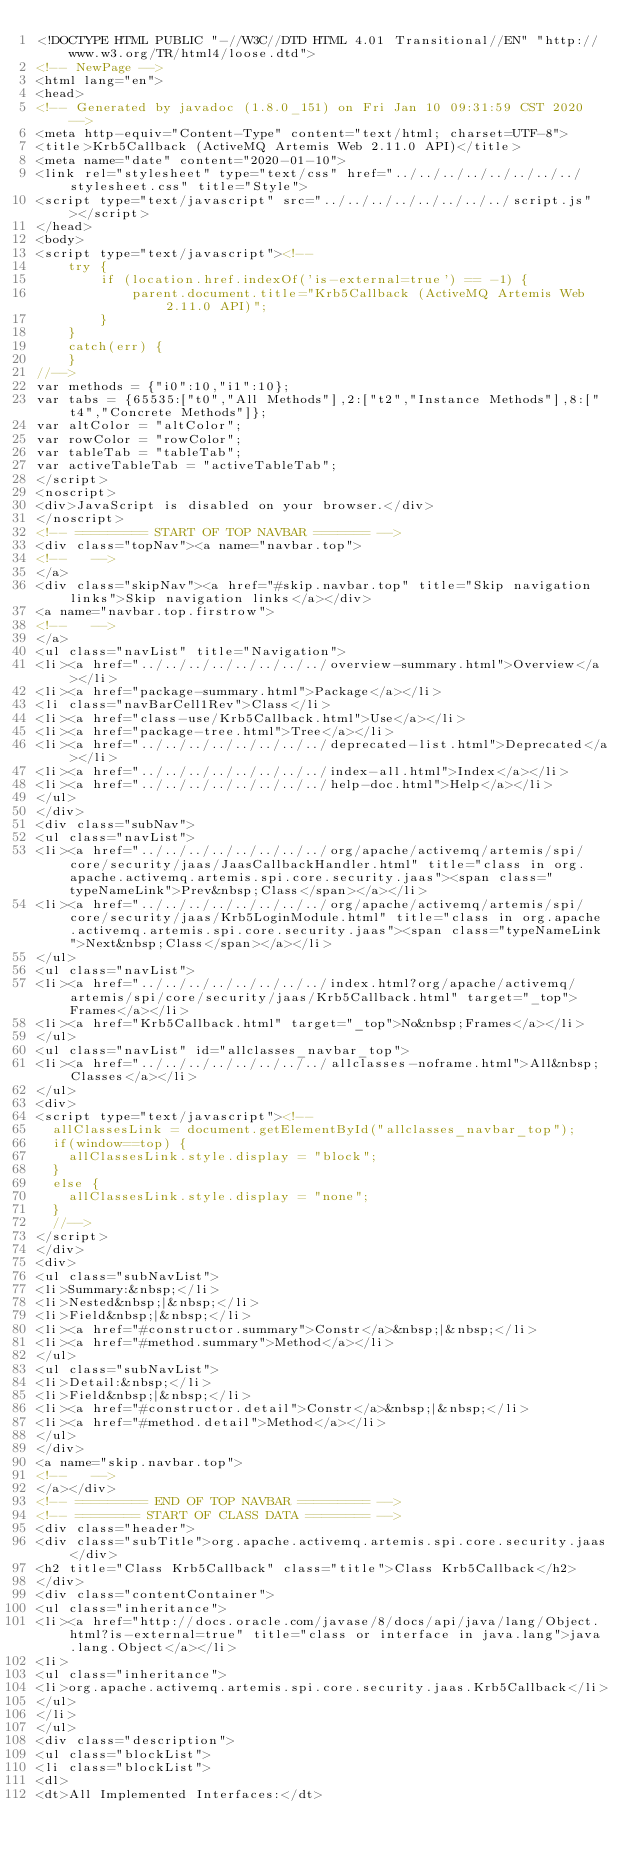Convert code to text. <code><loc_0><loc_0><loc_500><loc_500><_HTML_><!DOCTYPE HTML PUBLIC "-//W3C//DTD HTML 4.01 Transitional//EN" "http://www.w3.org/TR/html4/loose.dtd">
<!-- NewPage -->
<html lang="en">
<head>
<!-- Generated by javadoc (1.8.0_151) on Fri Jan 10 09:31:59 CST 2020 -->
<meta http-equiv="Content-Type" content="text/html; charset=UTF-8">
<title>Krb5Callback (ActiveMQ Artemis Web 2.11.0 API)</title>
<meta name="date" content="2020-01-10">
<link rel="stylesheet" type="text/css" href="../../../../../../../../stylesheet.css" title="Style">
<script type="text/javascript" src="../../../../../../../../script.js"></script>
</head>
<body>
<script type="text/javascript"><!--
    try {
        if (location.href.indexOf('is-external=true') == -1) {
            parent.document.title="Krb5Callback (ActiveMQ Artemis Web 2.11.0 API)";
        }
    }
    catch(err) {
    }
//-->
var methods = {"i0":10,"i1":10};
var tabs = {65535:["t0","All Methods"],2:["t2","Instance Methods"],8:["t4","Concrete Methods"]};
var altColor = "altColor";
var rowColor = "rowColor";
var tableTab = "tableTab";
var activeTableTab = "activeTableTab";
</script>
<noscript>
<div>JavaScript is disabled on your browser.</div>
</noscript>
<!-- ========= START OF TOP NAVBAR ======= -->
<div class="topNav"><a name="navbar.top">
<!--   -->
</a>
<div class="skipNav"><a href="#skip.navbar.top" title="Skip navigation links">Skip navigation links</a></div>
<a name="navbar.top.firstrow">
<!--   -->
</a>
<ul class="navList" title="Navigation">
<li><a href="../../../../../../../../overview-summary.html">Overview</a></li>
<li><a href="package-summary.html">Package</a></li>
<li class="navBarCell1Rev">Class</li>
<li><a href="class-use/Krb5Callback.html">Use</a></li>
<li><a href="package-tree.html">Tree</a></li>
<li><a href="../../../../../../../../deprecated-list.html">Deprecated</a></li>
<li><a href="../../../../../../../../index-all.html">Index</a></li>
<li><a href="../../../../../../../../help-doc.html">Help</a></li>
</ul>
</div>
<div class="subNav">
<ul class="navList">
<li><a href="../../../../../../../../org/apache/activemq/artemis/spi/core/security/jaas/JaasCallbackHandler.html" title="class in org.apache.activemq.artemis.spi.core.security.jaas"><span class="typeNameLink">Prev&nbsp;Class</span></a></li>
<li><a href="../../../../../../../../org/apache/activemq/artemis/spi/core/security/jaas/Krb5LoginModule.html" title="class in org.apache.activemq.artemis.spi.core.security.jaas"><span class="typeNameLink">Next&nbsp;Class</span></a></li>
</ul>
<ul class="navList">
<li><a href="../../../../../../../../index.html?org/apache/activemq/artemis/spi/core/security/jaas/Krb5Callback.html" target="_top">Frames</a></li>
<li><a href="Krb5Callback.html" target="_top">No&nbsp;Frames</a></li>
</ul>
<ul class="navList" id="allclasses_navbar_top">
<li><a href="../../../../../../../../allclasses-noframe.html">All&nbsp;Classes</a></li>
</ul>
<div>
<script type="text/javascript"><!--
  allClassesLink = document.getElementById("allclasses_navbar_top");
  if(window==top) {
    allClassesLink.style.display = "block";
  }
  else {
    allClassesLink.style.display = "none";
  }
  //-->
</script>
</div>
<div>
<ul class="subNavList">
<li>Summary:&nbsp;</li>
<li>Nested&nbsp;|&nbsp;</li>
<li>Field&nbsp;|&nbsp;</li>
<li><a href="#constructor.summary">Constr</a>&nbsp;|&nbsp;</li>
<li><a href="#method.summary">Method</a></li>
</ul>
<ul class="subNavList">
<li>Detail:&nbsp;</li>
<li>Field&nbsp;|&nbsp;</li>
<li><a href="#constructor.detail">Constr</a>&nbsp;|&nbsp;</li>
<li><a href="#method.detail">Method</a></li>
</ul>
</div>
<a name="skip.navbar.top">
<!--   -->
</a></div>
<!-- ========= END OF TOP NAVBAR ========= -->
<!-- ======== START OF CLASS DATA ======== -->
<div class="header">
<div class="subTitle">org.apache.activemq.artemis.spi.core.security.jaas</div>
<h2 title="Class Krb5Callback" class="title">Class Krb5Callback</h2>
</div>
<div class="contentContainer">
<ul class="inheritance">
<li><a href="http://docs.oracle.com/javase/8/docs/api/java/lang/Object.html?is-external=true" title="class or interface in java.lang">java.lang.Object</a></li>
<li>
<ul class="inheritance">
<li>org.apache.activemq.artemis.spi.core.security.jaas.Krb5Callback</li>
</ul>
</li>
</ul>
<div class="description">
<ul class="blockList">
<li class="blockList">
<dl>
<dt>All Implemented Interfaces:</dt></code> 